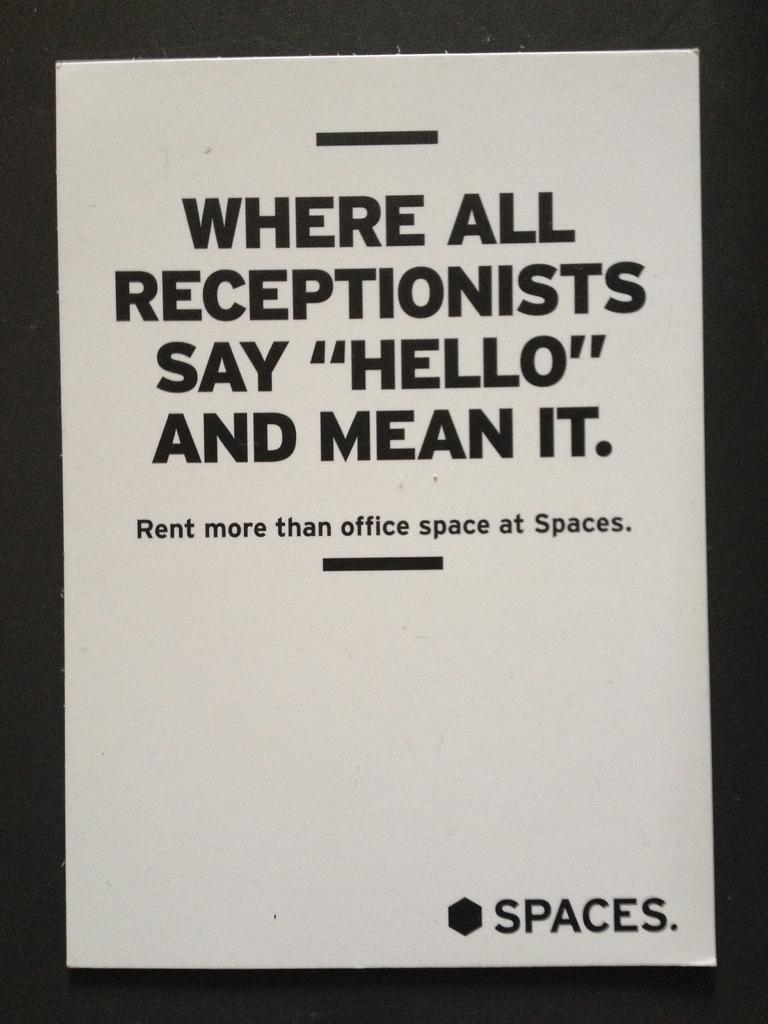<image>
Summarize the visual content of the image. a white paper that has spaces at the bottom right 